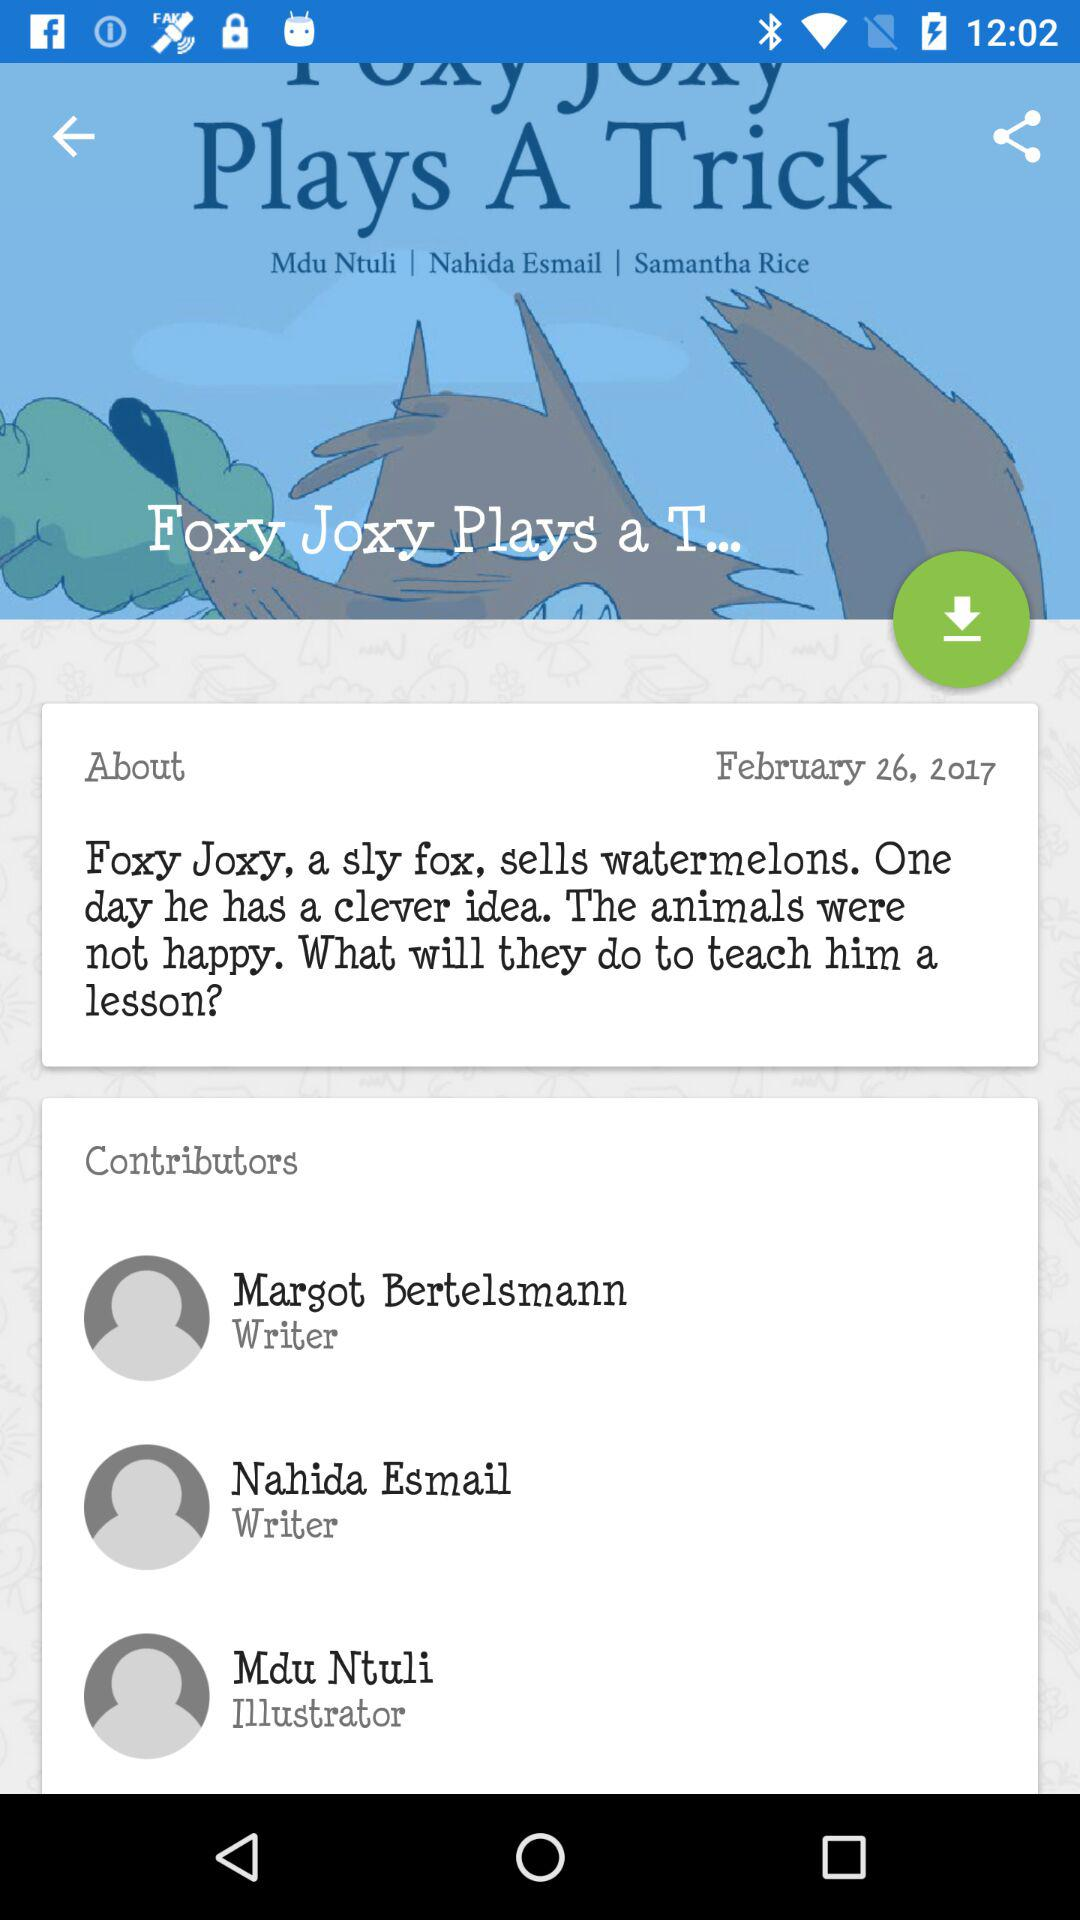When was the story book published? The story book was published on February 26, 2017. 